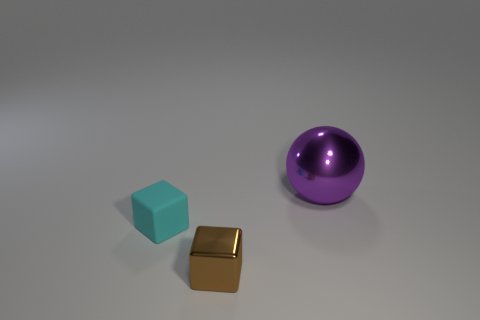Add 3 blue metallic spheres. How many objects exist? 6 Subtract all balls. How many objects are left? 2 Subtract all cyan shiny cylinders. Subtract all shiny spheres. How many objects are left? 2 Add 1 metallic spheres. How many metallic spheres are left? 2 Add 1 tiny brown blocks. How many tiny brown blocks exist? 2 Subtract 0 yellow cylinders. How many objects are left? 3 